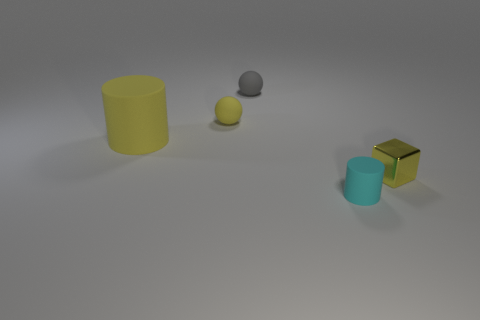Add 1 yellow blocks. How many objects exist? 6 Subtract all cylinders. How many objects are left? 3 Add 3 tiny yellow things. How many tiny yellow things exist? 5 Subtract 0 red spheres. How many objects are left? 5 Subtract all tiny cylinders. Subtract all tiny gray rubber spheres. How many objects are left? 3 Add 2 small yellow cubes. How many small yellow cubes are left? 3 